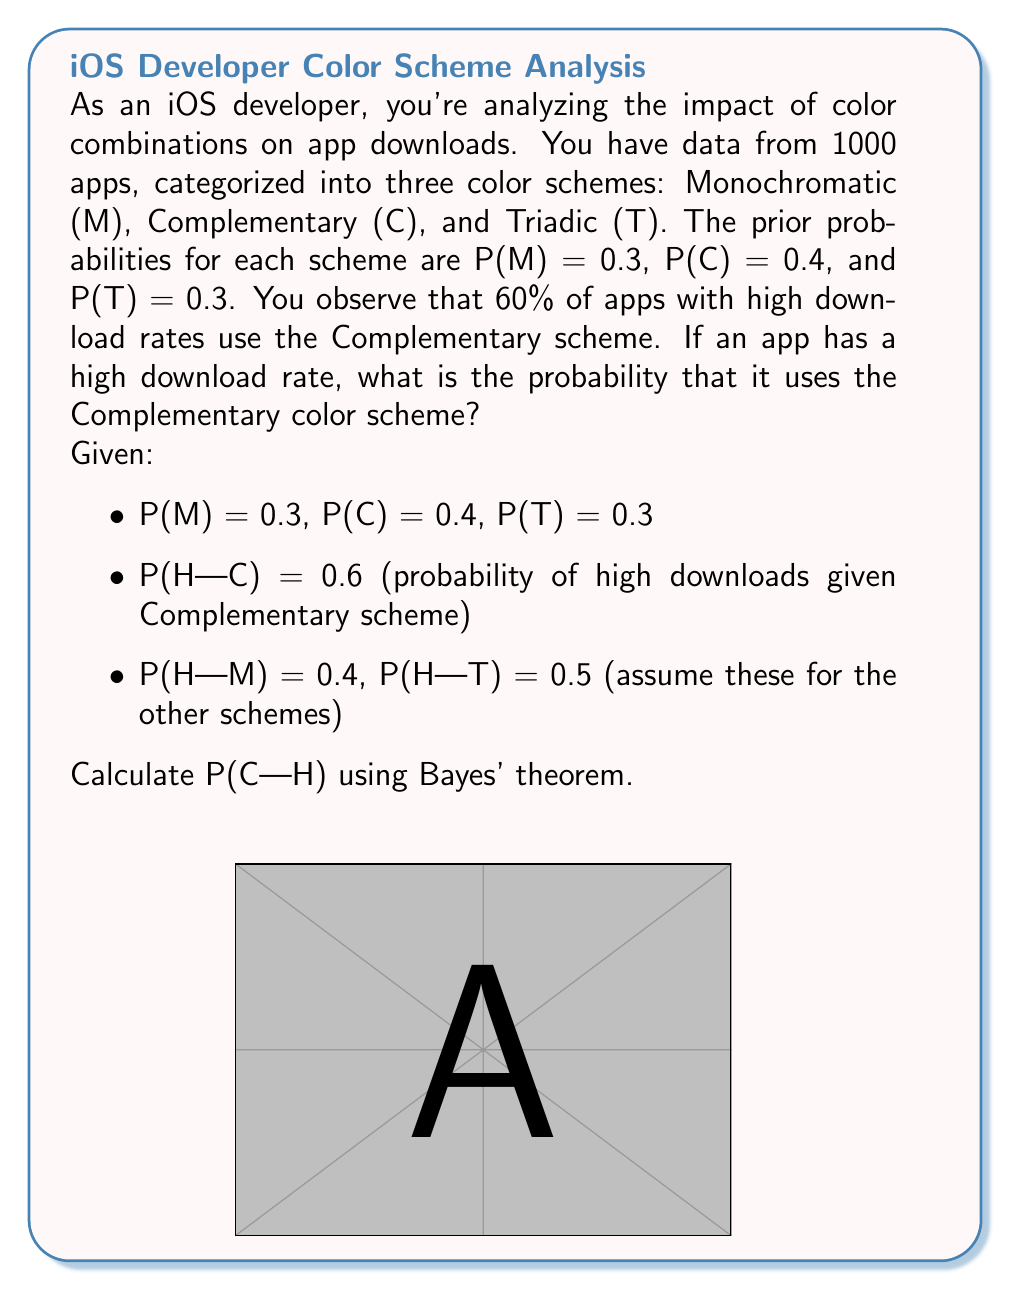Help me with this question. To solve this problem, we'll use Bayes' theorem:

$$P(C|H) = \frac{P(H|C) \cdot P(C)}{P(H)}$$

Step 1: We have P(H|C) and P(C), but we need to calculate P(H).

Step 2: Calculate P(H) using the law of total probability:
$$P(H) = P(H|M)P(M) + P(H|C)P(C) + P(H|T)P(T)$$
$$P(H) = 0.4 \cdot 0.3 + 0.6 \cdot 0.4 + 0.5 \cdot 0.3$$
$$P(H) = 0.12 + 0.24 + 0.15 = 0.51$$

Step 3: Now we can apply Bayes' theorem:
$$P(C|H) = \frac{0.6 \cdot 0.4}{0.51}$$

Step 4: Simplify the fraction:
$$P(C|H) = \frac{0.24}{0.51} \approx 0.4706$$

Therefore, the probability that an app with a high download rate uses the Complementary color scheme is approximately 0.4706 or 47.06%.
Answer: 0.4706 